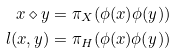<formula> <loc_0><loc_0><loc_500><loc_500>x \diamond y & = \pi _ { X } ( \phi ( x ) \phi ( y ) ) \\ l ( x , y ) & = \pi _ { H } ( \phi ( x ) \phi ( y ) )</formula> 